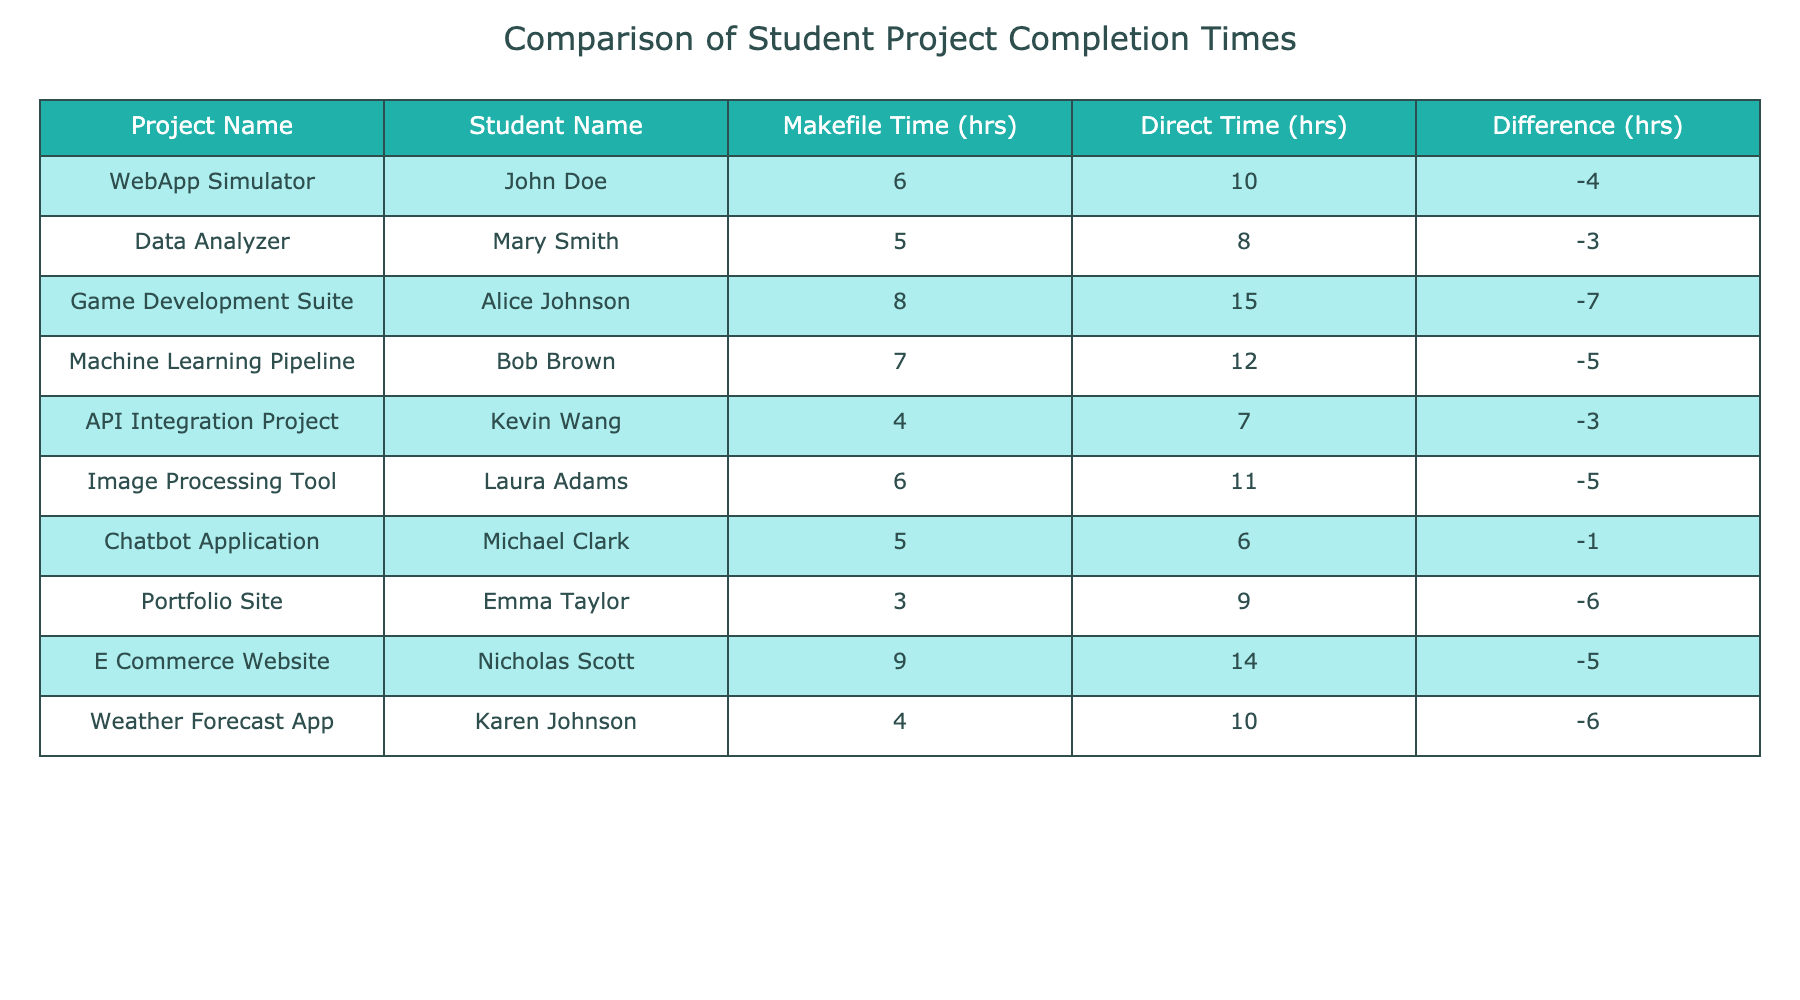What's the completion time for the "WebApp Simulator" project using Makefiles? According to the table, the Makefile completion time for the "WebApp Simulator" project is listed as 6 hours.
Answer: 6 hours What is the difference in completion times for the "Data Analyzer" project? The table shows that the Makefile completion time is 5 hours and the Direct Compilation completion time is 8 hours. The difference is 5 - 8 = -3 hours.
Answer: -3 hours Did any student complete their project using Makefiles faster than they did with Direct Compilation? Yes, if we look at the "Portfolio Site" project by Emma Taylor, the Makefile completion time was 3 hours while the Direct Compilation time was 9 hours, which indicates that Makefiles were faster.
Answer: Yes What is the average completion time using Makefiles across all projects? To find the average, we sum the Makefile completion times: 6 + 5 + 8 + 7 + 4 + 6 + 5 + 3 + 9 + 4 = 57 hours. There are 10 projects, so the average is 57 / 10 = 5.7 hours.
Answer: 5.7 hours Which project had the largest difference in completion times, and what is that difference? The project with the largest difference is the "Game Development Suite," with a completion difference of -7 hours (8 hours using Makefiles and 15 hours using Direct Compilation).
Answer: Game Development Suite, -7 hours What is the total time saved when using Makefiles instead of Direct Compilation? We can calculate the total time saved by adding up the differences (which will be negative values) and turning them into positives: 4 + 3 + 7 + 5 + 3 + 5 + 1 + 6 + 5 + 6 = 45 hours saved when using Makefiles.
Answer: 45 hours Did all projects complete faster using Makefiles compared to Direct Compilation? No, the analysis shows that the "Chatbot Application" project only had a difference of -1 hour, meaning it was not quicker using Makefiles.
Answer: No How many projects had a completion time difference of -5 hours or less? Upon reviewing the table, there are 5 projects that have a completion time difference of -5 hours or less: "WebApp Simulator," "Data Analyzer," "Machine Learning Pipeline," "Image Processing Tool," and "Weather Forecast App."
Answer: 5 projects 